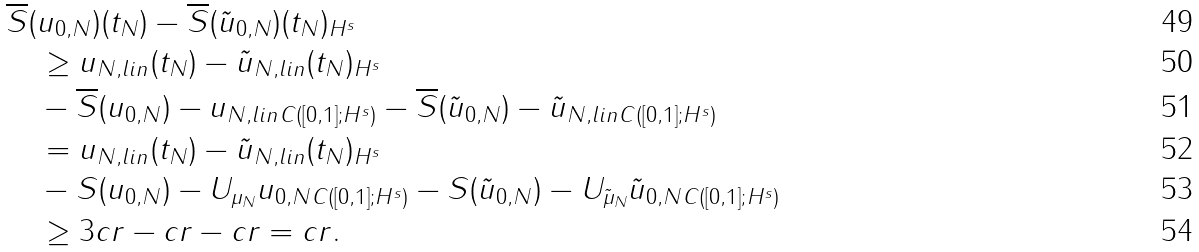Convert formula to latex. <formula><loc_0><loc_0><loc_500><loc_500>& \| \overline { S } ( u _ { 0 , N } ) ( t _ { N } ) - \overline { S } ( \tilde { u } _ { 0 , N } ) ( t _ { N } ) \| _ { H ^ { s } } \\ & \quad \geq \| u _ { N , l i n } ( t _ { N } ) - \tilde { u } _ { N , l i n } ( t _ { N } ) \| _ { H ^ { s } } \\ & \quad - \| \overline { S } ( u _ { 0 , N } ) - u _ { N , l i n } \| _ { C ( [ 0 , 1 ] ; H ^ { s } ) } - \| \overline { S } ( \tilde { u } _ { 0 , N } ) - \tilde { u } _ { N , l i n } \| _ { C ( [ 0 , 1 ] ; H ^ { s } ) } \\ & \quad = \| u _ { N , l i n } ( t _ { N } ) - \tilde { u } _ { N , l i n } ( t _ { N } ) \| _ { H ^ { s } } \\ & \quad - \| S ( u _ { 0 , N } ) - U _ { \mu _ { N } } u _ { 0 , N } \| _ { C ( [ 0 , 1 ] ; H ^ { s } ) } - \| S ( \tilde { u } _ { 0 , N } ) - U _ { \tilde { \mu } _ { N } } \tilde { u } _ { 0 , N } \| _ { C ( [ 0 , 1 ] ; H ^ { s } ) } \\ & \quad \geq 3 c r - c r - c r = c r .</formula> 